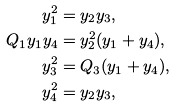Convert formula to latex. <formula><loc_0><loc_0><loc_500><loc_500>y _ { 1 } ^ { 2 } & = y _ { 2 } y _ { 3 } , \\ Q _ { 1 } y _ { 1 } y _ { 4 } & = y _ { 2 } ^ { 2 } ( y _ { 1 } + y _ { 4 } ) , \\ y _ { 3 } ^ { 2 } & = Q _ { 3 } ( y _ { 1 } + y _ { 4 } ) , \\ y _ { 4 } ^ { 2 } & = y _ { 2 } y _ { 3 } ,</formula> 